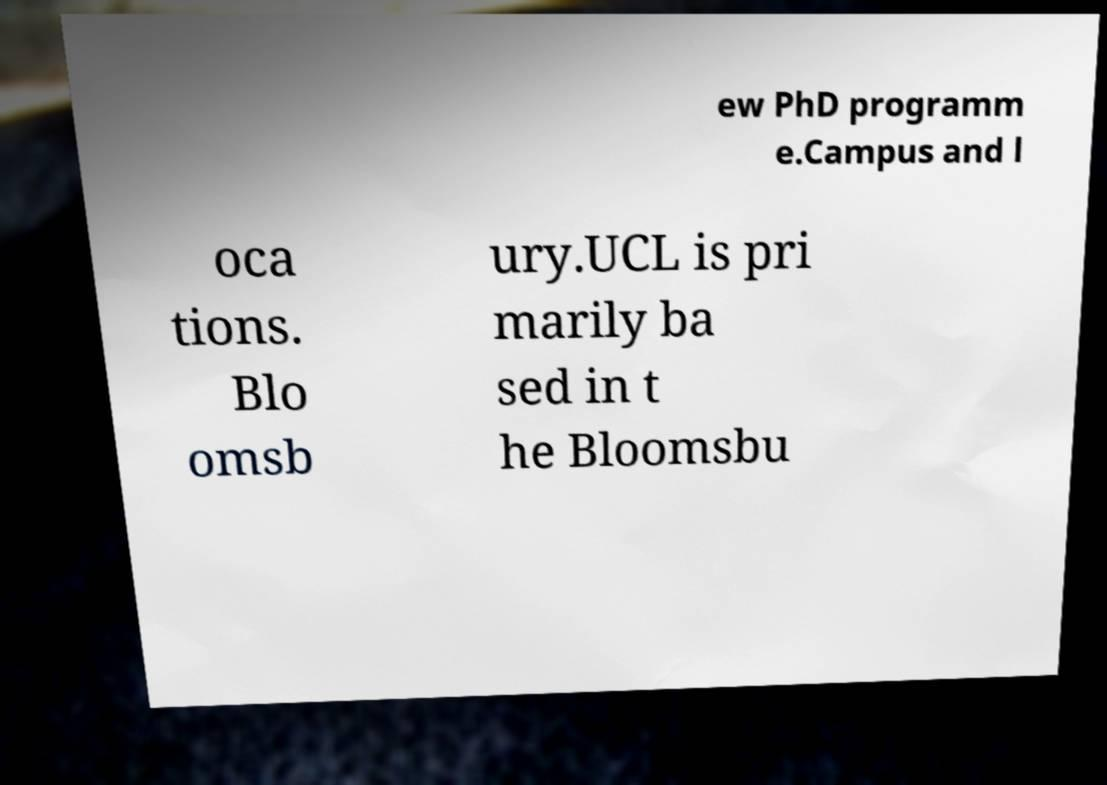Can you read and provide the text displayed in the image?This photo seems to have some interesting text. Can you extract and type it out for me? ew PhD programm e.Campus and l oca tions. Blo omsb ury.UCL is pri marily ba sed in t he Bloomsbu 